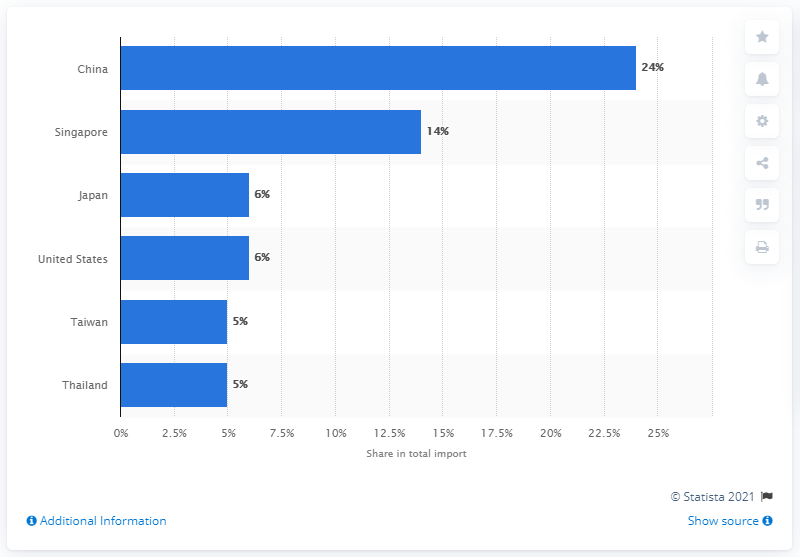Point out several critical features in this image. In 2019, Malaysia's most important import partner was China, which accounted for a significant portion of the country's total imports. 